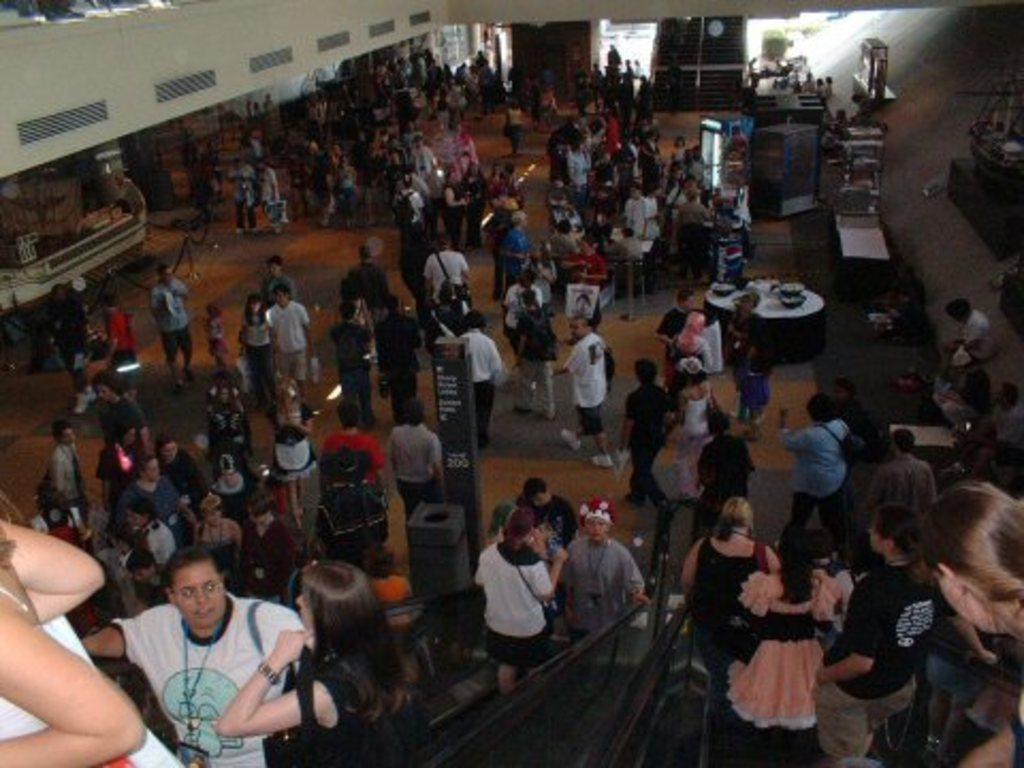In one or two sentences, can you explain what this image depicts? This picture is taken inside the room. In this image, we can see a group of people, table. On that table, we can see some bowls. On the right side, we can see some electronic gadgets. On the left side, we can see air conditioner. In the right corner, we can see a woman. 